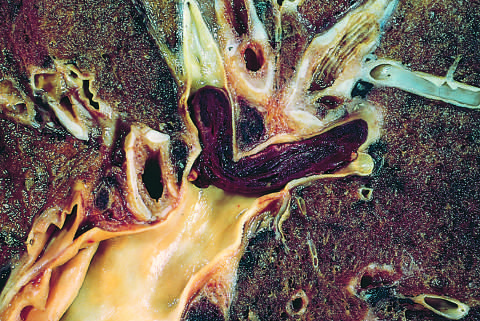s embolus derived from a lower-extremity deep venous thrombus lodged in a pulmonary artery branch?
Answer the question using a single word or phrase. Yes 